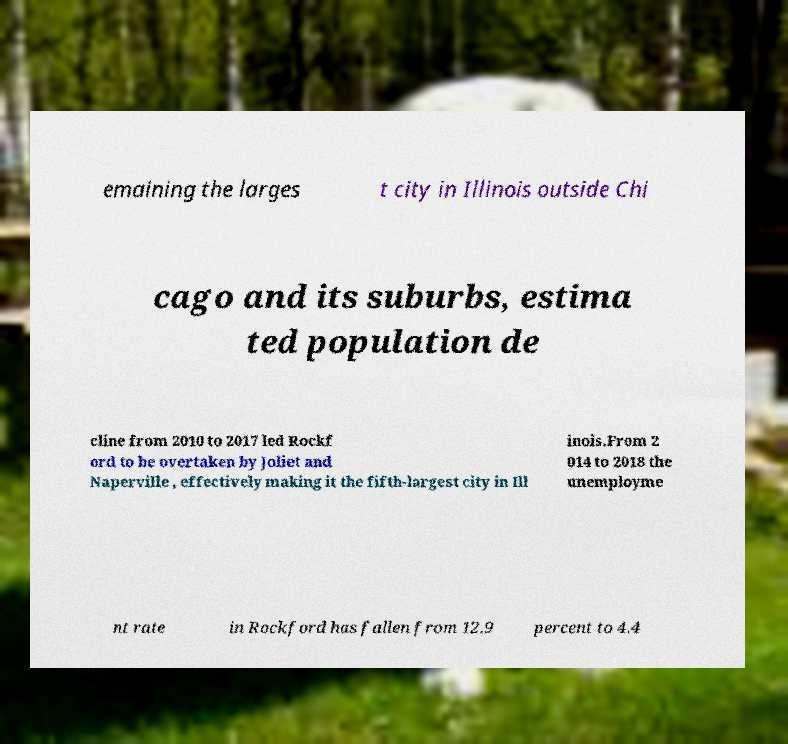Please read and relay the text visible in this image. What does it say? emaining the larges t city in Illinois outside Chi cago and its suburbs, estima ted population de cline from 2010 to 2017 led Rockf ord to be overtaken by Joliet and Naperville , effectively making it the fifth-largest city in Ill inois.From 2 014 to 2018 the unemployme nt rate in Rockford has fallen from 12.9 percent to 4.4 